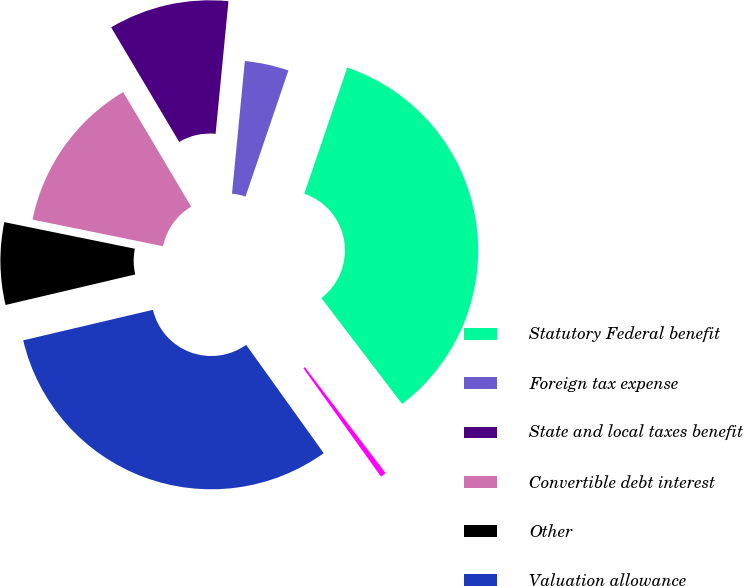Convert chart. <chart><loc_0><loc_0><loc_500><loc_500><pie_chart><fcel>Statutory Federal benefit<fcel>Foreign tax expense<fcel>State and local taxes benefit<fcel>Convertible debt interest<fcel>Other<fcel>Valuation allowance<fcel>Provision for income taxes<nl><fcel>34.41%<fcel>3.68%<fcel>10.07%<fcel>13.27%<fcel>6.88%<fcel>31.21%<fcel>0.48%<nl></chart> 